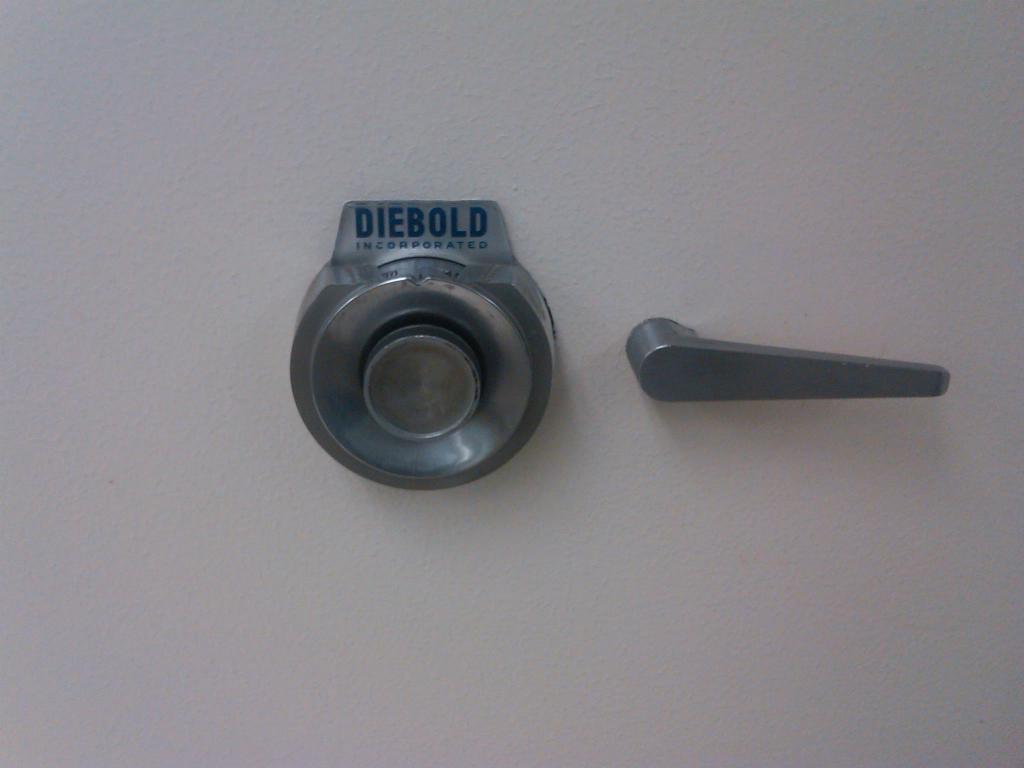How would you summarize this image in a sentence or two? In this picture there are two metal objects on the wall. There is a text on the object. 